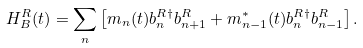Convert formula to latex. <formula><loc_0><loc_0><loc_500><loc_500>H ^ { R } _ { B } ( t ) = \sum _ { n } \left [ m _ { n } ( t ) b _ { n } ^ { R \dagger } b _ { n + 1 } ^ { R } + m _ { n - 1 } ^ { * } ( t ) b _ { n } ^ { R \dagger } b _ { n - 1 } ^ { R } \right ] .</formula> 